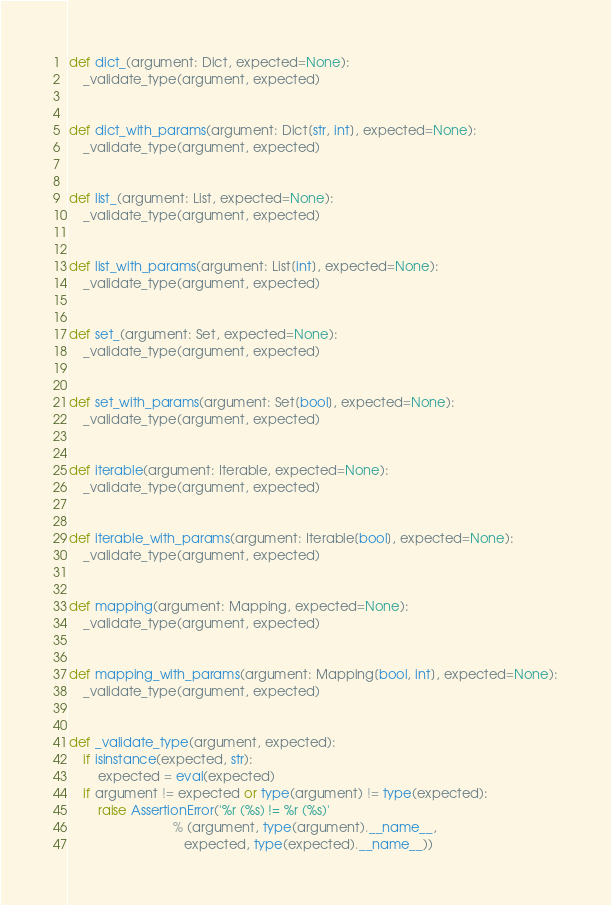Convert code to text. <code><loc_0><loc_0><loc_500><loc_500><_Python_>
def dict_(argument: Dict, expected=None):
    _validate_type(argument, expected)


def dict_with_params(argument: Dict[str, int], expected=None):
    _validate_type(argument, expected)


def list_(argument: List, expected=None):
    _validate_type(argument, expected)


def list_with_params(argument: List[int], expected=None):
    _validate_type(argument, expected)


def set_(argument: Set, expected=None):
    _validate_type(argument, expected)


def set_with_params(argument: Set[bool], expected=None):
    _validate_type(argument, expected)


def iterable(argument: Iterable, expected=None):
    _validate_type(argument, expected)


def iterable_with_params(argument: Iterable[bool], expected=None):
    _validate_type(argument, expected)


def mapping(argument: Mapping, expected=None):
    _validate_type(argument, expected)


def mapping_with_params(argument: Mapping[bool, int], expected=None):
    _validate_type(argument, expected)


def _validate_type(argument, expected):
    if isinstance(expected, str):
        expected = eval(expected)
    if argument != expected or type(argument) != type(expected):
        raise AssertionError('%r (%s) != %r (%s)'
                             % (argument, type(argument).__name__,
                                expected, type(expected).__name__))
</code> 